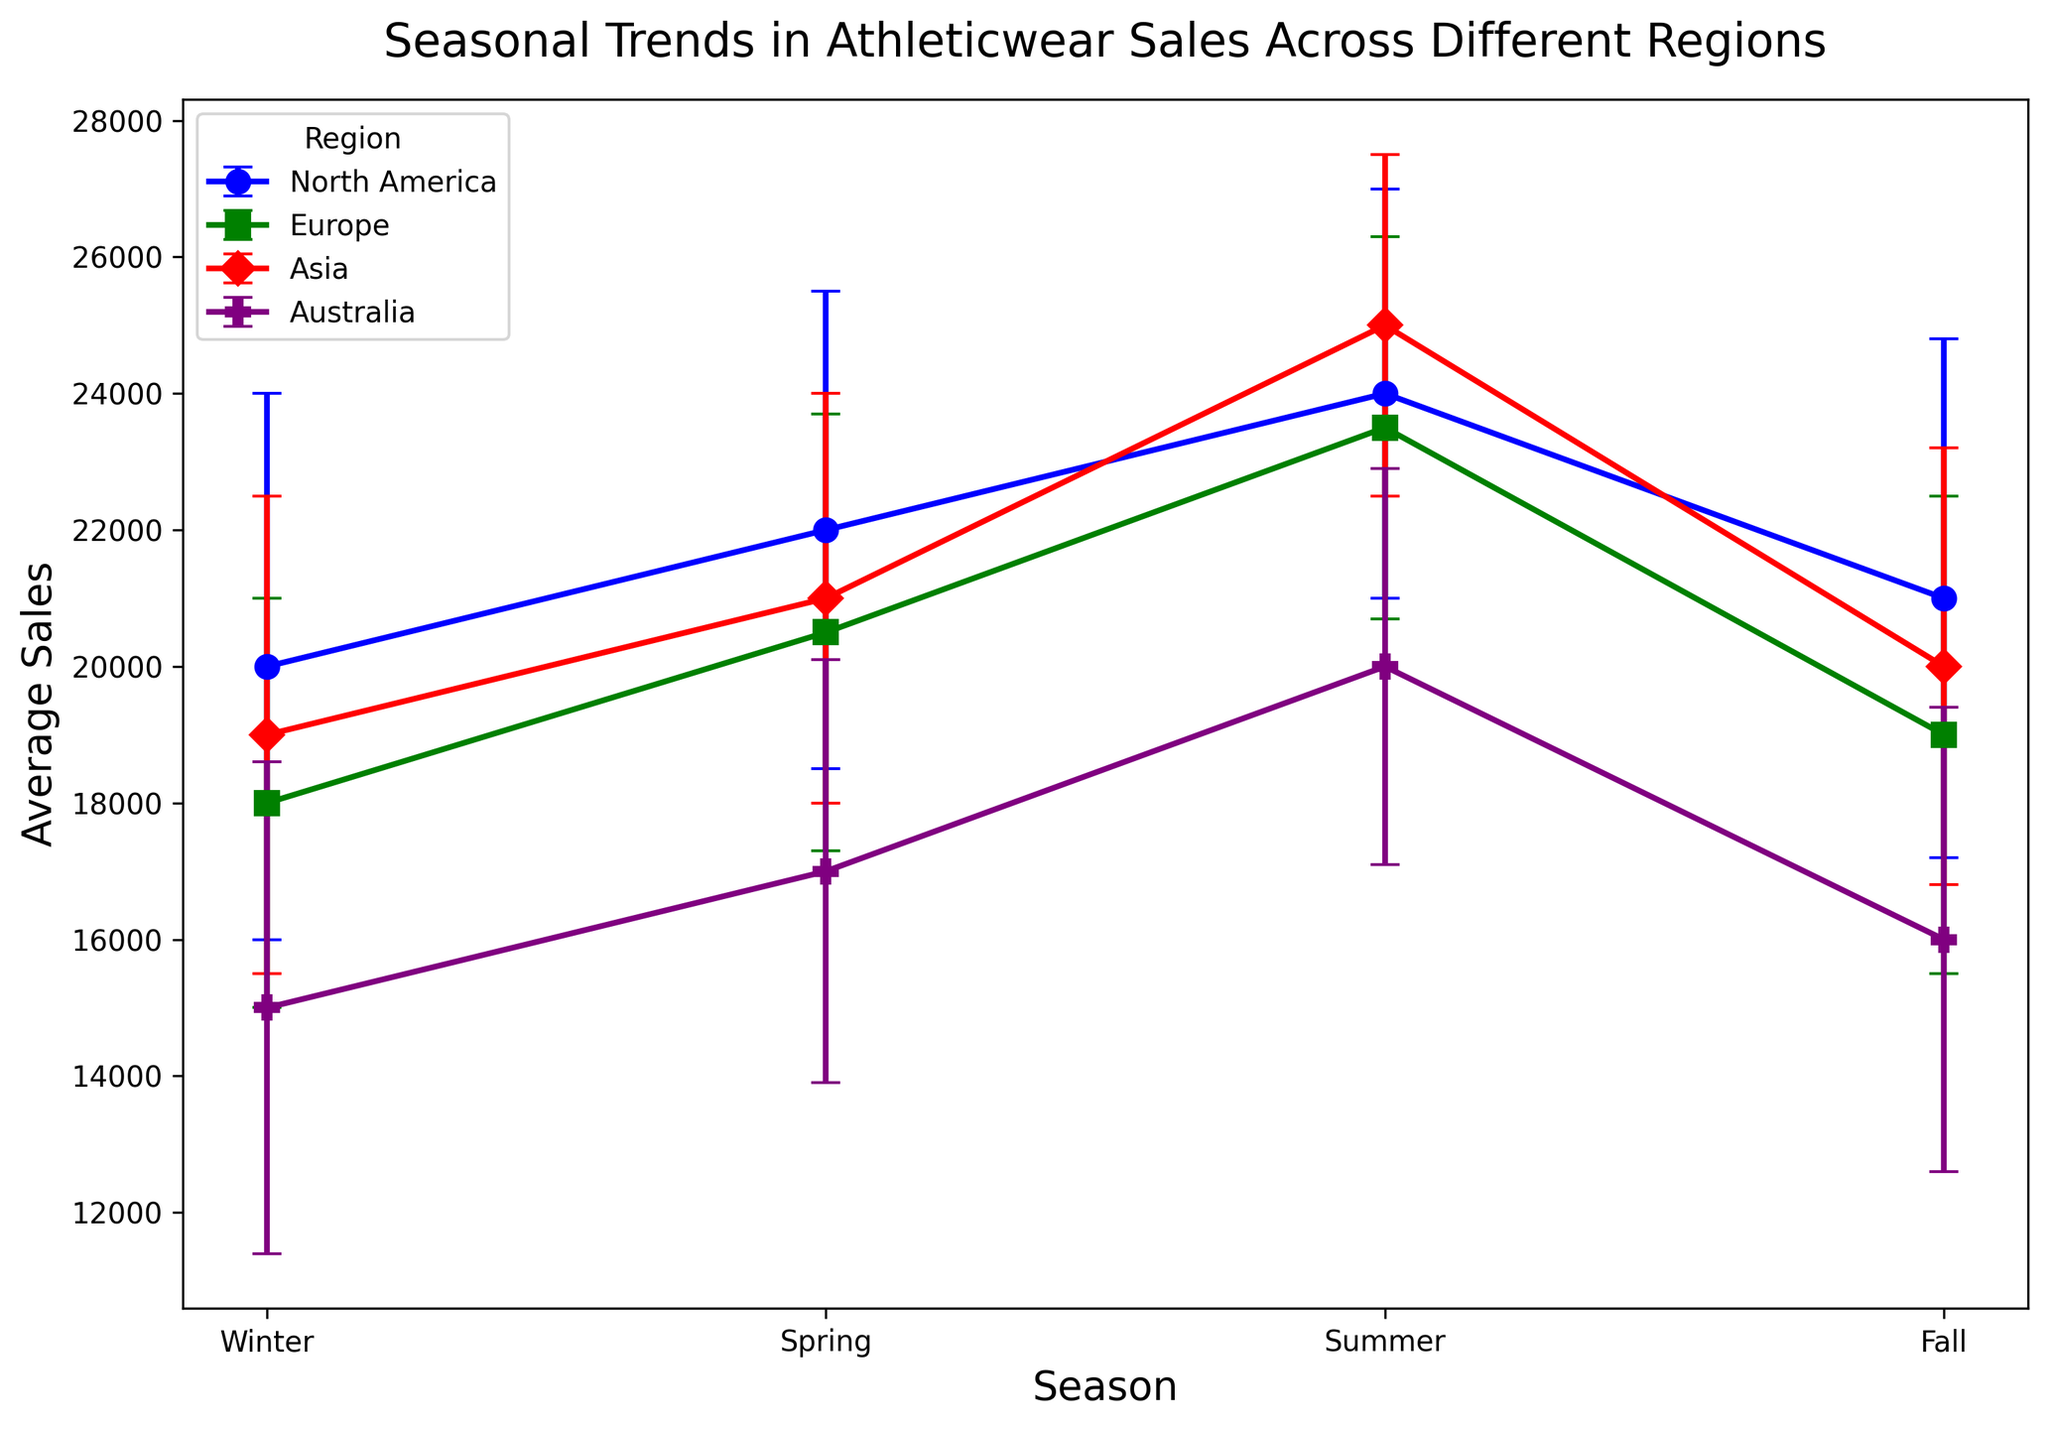What season has the highest average sales in North America? Look at the data points for North America and identify which season has the highest point on the graph. The highest value occurs in Summer with an average sales of 24000.
Answer: Summer Which region has the lowest average sales in Winter? Look at the lowest point of the Winter series across all regions. The lowest average sales in Winter is in Australia with 15000.
Answer: Australia What's the range of sales for Europe during Spring (considering the error bars)? Determine the average sales for Europe in Spring (20500) and add/subtract the standard deviation (3200). The range is 20500 - 3200 to 20500 + 3200, which is 17300 to 23700.
Answer: 17300 to 23700 How do the average Summer sales in Asia compare with those in Europe? Look at the Summer points for both Asia and Europe. Asia has an average sales of 25000 whereas Europe has 23500. Asia's average Summer sales are higher.
Answer: Asia's are higher What is the total average sales for Asia across all seasons? Sum the average sales for Asia for all seasons (19000 + 21000 + 25000 + 20000) to get 85000.
Answer: 85000 In which season does Australia have the highest average sales? Identify the highest point on Australia's series. The highest is in Summer with an average of 20000.
Answer: Summer Which region has the smallest variability in sales during Summer, considering the error bars? The smallest variability is indicated by the shortest error bar in Summer. Asia has a standard deviation of 2500, which is the smallest variability compared to other regions.
Answer: Asia What are the average sales and standard deviation for Fall in Europe? Look at the specific point for Europe in Fall. The average sales are 19000 and the standard deviation is 3500.
Answer: 19000 and 3500 Compare the Spring sales variability between North America and Australia. Which has a larger variance? Compare the length of the error bars for Spring in both regions. North America's standard deviation is 3500, while Australia's is 3100. North America has a larger variance.
Answer: North America What is the difference in average Winter sales between Europe and the next highest region? Europe’s average Winter sales are 18000. The next highest is North America with 20000. The difference is 20000 - 18000 = 2000.
Answer: 2000 